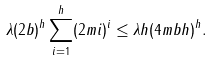<formula> <loc_0><loc_0><loc_500><loc_500>\lambda ( 2 b ) ^ { h } \sum _ { i = 1 } ^ { h } ( 2 m i ) ^ { i } \leq \lambda h ( 4 m b h ) ^ { h } .</formula> 